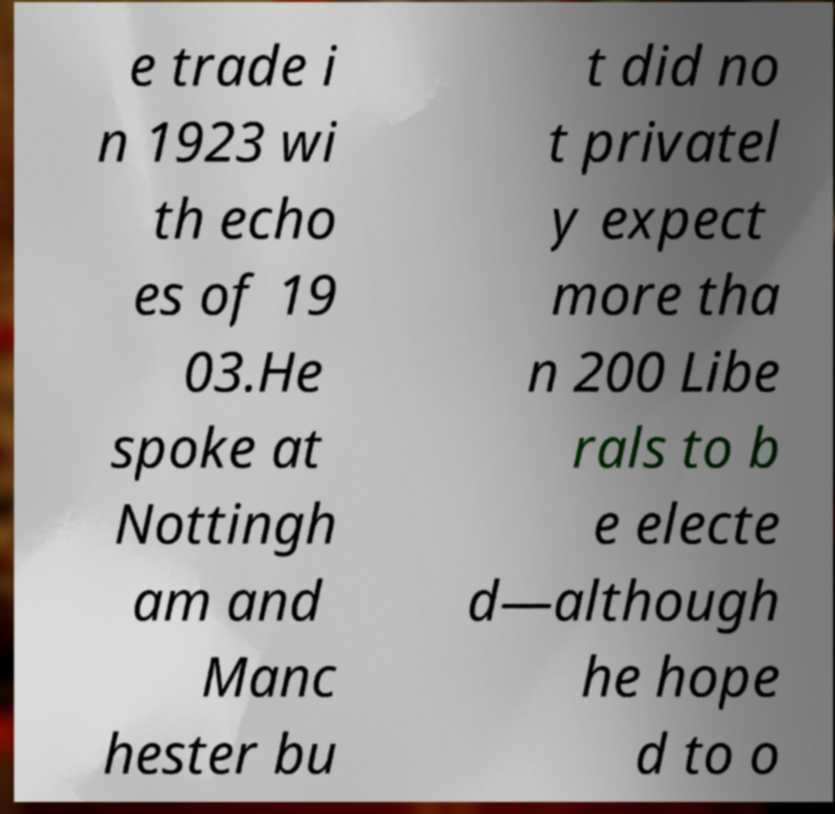Could you assist in decoding the text presented in this image and type it out clearly? e trade i n 1923 wi th echo es of 19 03.He spoke at Nottingh am and Manc hester bu t did no t privatel y expect more tha n 200 Libe rals to b e electe d—although he hope d to o 